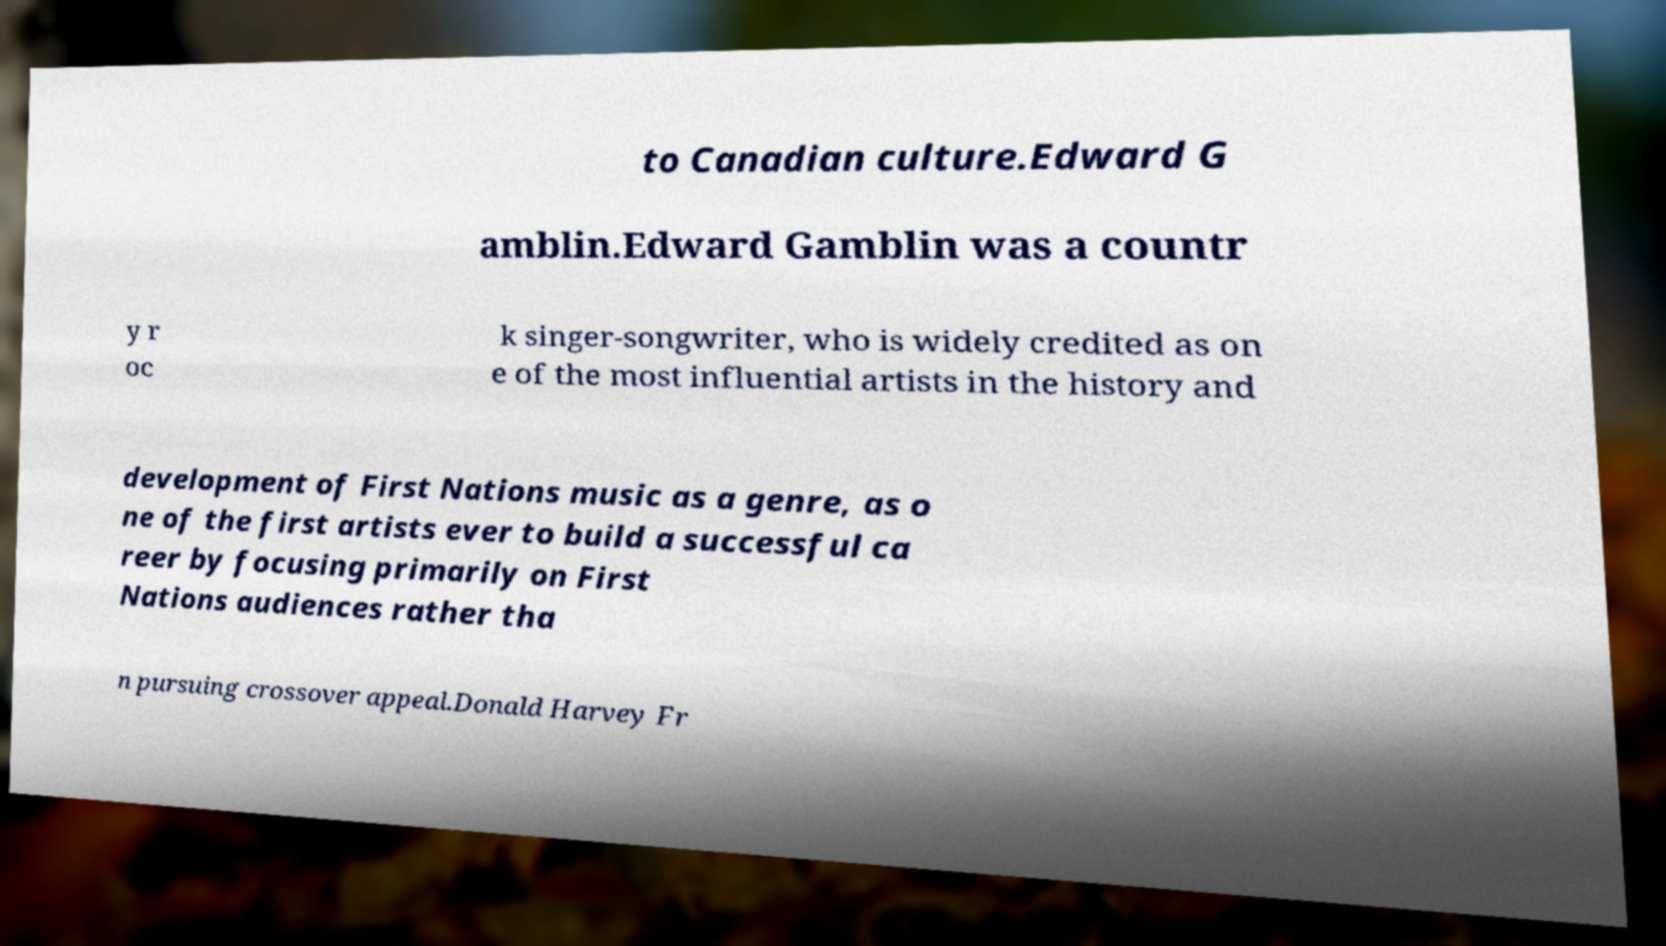I need the written content from this picture converted into text. Can you do that? to Canadian culture.Edward G amblin.Edward Gamblin was a countr y r oc k singer-songwriter, who is widely credited as on e of the most influential artists in the history and development of First Nations music as a genre, as o ne of the first artists ever to build a successful ca reer by focusing primarily on First Nations audiences rather tha n pursuing crossover appeal.Donald Harvey Fr 